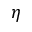<formula> <loc_0><loc_0><loc_500><loc_500>\eta</formula> 